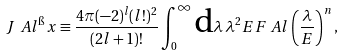Convert formula to latex. <formula><loc_0><loc_0><loc_500><loc_500>J _ { \ } A l ^ { \i } x \equiv \frac { 4 \pi ( - 2 ) ^ { l } ( l ! ) ^ { 2 } } { ( 2 l + 1 ) ! } \int ^ { \infty } _ { 0 } \text {d} \lambda \, \lambda ^ { 2 } E F _ { \ } A l \left ( \frac { \lambda } { E } \right ) ^ { n } ,</formula> 